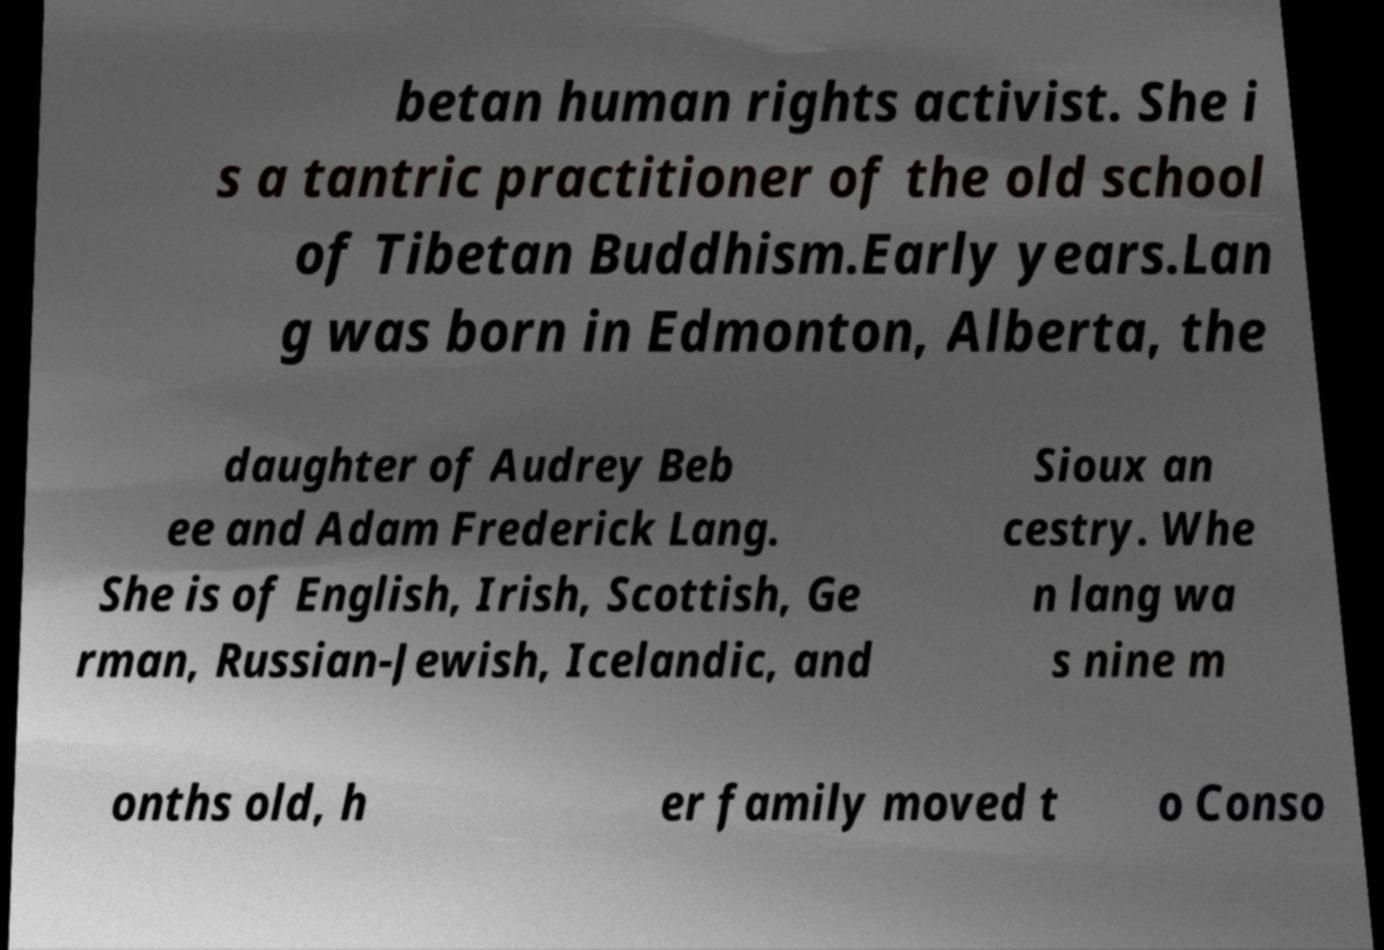Please identify and transcribe the text found in this image. betan human rights activist. She i s a tantric practitioner of the old school of Tibetan Buddhism.Early years.Lan g was born in Edmonton, Alberta, the daughter of Audrey Beb ee and Adam Frederick Lang. She is of English, Irish, Scottish, Ge rman, Russian-Jewish, Icelandic, and Sioux an cestry. Whe n lang wa s nine m onths old, h er family moved t o Conso 